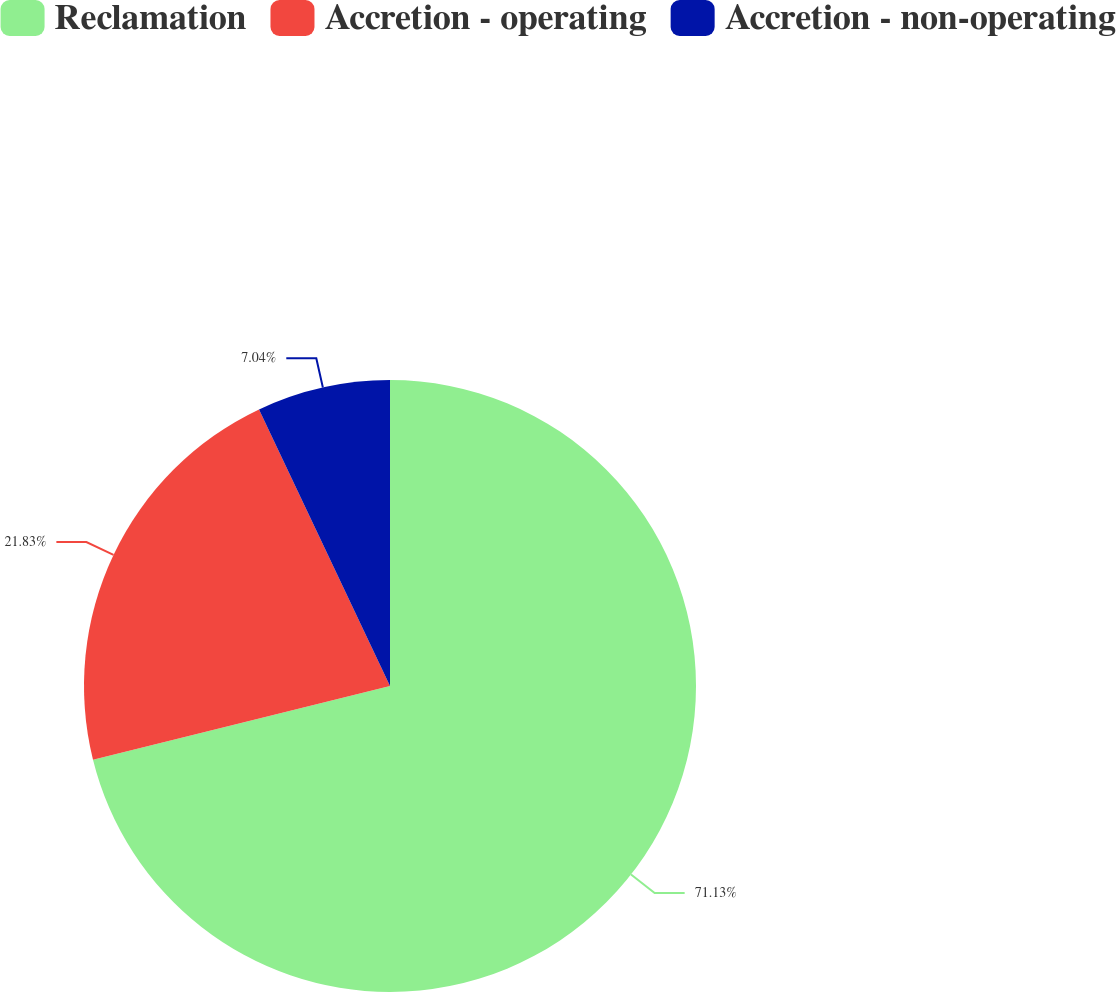Convert chart to OTSL. <chart><loc_0><loc_0><loc_500><loc_500><pie_chart><fcel>Reclamation<fcel>Accretion - operating<fcel>Accretion - non-operating<nl><fcel>71.13%<fcel>21.83%<fcel>7.04%<nl></chart> 